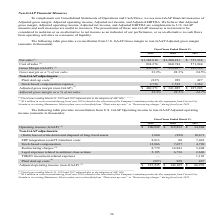From Kemet Corporation's financial document, Which years does the table provide information for the  reconciliation from U.S. GAAP Gross margin to non-GAAP Adjusted gross margin? The document contains multiple relevant values: 2019, 2018, 2017. From the document: "2019 2018 2017 2019 2018 2017 2019 2018 2017..." Also, What were the net sales in 2018? According to the financial document, 1,200,181 (in thousands). The relevant text states: "Net sales (1) $1,382,818 $1,200,181 $ 757,338..." Also, What was the gross margin (GAAP) in 2017? According to the financial document, 185,394 (in thousands). The relevant text states: "Gross Margin (GAAP) (1) 458,542 339,437 185,394..." Also, can you calculate: What was the change in net sales between 2017 and 2019? Based on the calculation: 1,382,818-757,338, the result is 625480 (in thousands). This is based on the information: "Net sales (1) $1,382,818 $1,200,181 $ 757,338 Net sales (1) $1,382,818 $1,200,181 $ 757,338..." The key data points involved are: 1,382,818, 757,338. Also, How many years did cost of sales exceed $800,000 thousand? Counting the relevant items in the document: 2019, 2018, I find 2 instances. The key data points involved are: 2018, 2019. Also, can you calculate: What was the percentage change in Stock-based compensation expense between 2018 and 2019? To answer this question, I need to perform calculations using the financial data. The calculation is: (2,756-1,519)/1,519, which equals 81.44 (percentage). This is based on the information: "Stock-based compensation expense 2,756 1,519 1,384 Stock-based compensation expense 2,756 1,519 1,384..." The key data points involved are: 1,519, 2,756. 